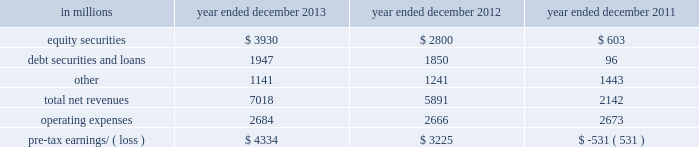Management 2019s discussion and analysis net revenues in equities were $ 8.21 billion for 2012 , essentially unchanged compared with 2011 .
Net revenues in securities services were significantly higher compared with 2011 , reflecting a gain of $ 494 million on the sale of our hedge fund administration business .
In addition , equities client execution net revenues were higher than 2011 , primarily reflecting significantly higher results in cash products , principally due to increased levels of client activity .
These increases were offset by lower commissions and fees , reflecting declines in the united states , europe and asia .
Our average daily volumes during 2012 were lower in each of these regions compared with 2011 , consistent with listed cash equity market volumes .
During 2012 , equities operated in an environment generally characterized by an increase in global equity prices and lower volatility levels .
The net loss attributable to the impact of changes in our own credit spreads on borrowings for which the fair value option was elected was $ 714 million ( $ 433 million and $ 281 million related to fixed income , currency and commodities client execution and equities client execution , respectively ) for 2012 , compared with a net gain of $ 596 million ( $ 399 million and $ 197 million related to fixed income , currency and commodities client execution and equities client execution , respectively ) for 2011 .
During 2012 , institutional client services operated in an environment generally characterized by continued broad market concerns and uncertainties , although positive developments helped to improve market conditions .
These developments included certain central bank actions to ease monetary policy and address funding risks for european financial institutions .
In addition , the u.s .
Economy posted stable to improving economic data , including favorable developments in unemployment and housing .
These improvements resulted in tighter credit spreads , higher global equity prices and lower levels of volatility .
However , concerns about the outlook for the global economy and continued political uncertainty , particularly the political debate in the united states surrounding the fiscal cliff , generally resulted in client risk aversion and lower activity levels .
Also , uncertainty over financial regulatory reform persisted .
Operating expenses were $ 12.48 billion for 2012 , 3% ( 3 % ) lower than 2011 , primarily due to lower brokerage , clearing , exchange and distribution fees , and lower impairment charges , partially offset by higher net provisions for litigation and regulatory proceedings .
Pre- tax earnings were $ 5.64 billion in 2012 , 27% ( 27 % ) higher than 2011 .
Investing & lending investing & lending includes our investing activities and the origination of loans to provide financing to clients .
These investments , some of which are consolidated , and loans are typically longer-term in nature .
We make investments , directly and indirectly through funds that we manage , in debt securities and loans , public and private equity securities , and real estate entities .
The table below presents the operating results of our investing & lending segment. .
2013 versus 2012 .
Net revenues in investing & lending were $ 7.02 billion for 2013 , 19% ( 19 % ) higher than 2012 , reflecting a significant increase in net gains from investments in equity securities , driven by company-specific events and stronger corporate performance , as well as significantly higher global equity prices .
In addition , net gains and net interest income from debt securities and loans were slightly higher , while other net revenues , related to our consolidated investments , were lower compared with 2012 .
If equity markets decline or credit spreads widen , net revenues in investing & lending would likely be negatively impacted .
Operating expenses were $ 2.68 billion for 2013 , essentially unchanged compared with 2012 .
Operating expenses during 2013 included lower impairment charges and lower operating expenses related to consolidated investments , partially offset by increased compensation and benefits expenses due to higher net revenues compared with 2012 .
Pre-tax earnings were $ 4.33 billion in 2013 , 34% ( 34 % ) higher than 2012 .
52 goldman sachs 2013 annual report .
Operating expenses for 2012 , were what percent of pre- tax earnings? 
Computations: (12.48 / 5.64)
Answer: 2.21277. Management 2019s discussion and analysis net revenues in equities were $ 8.21 billion for 2012 , essentially unchanged compared with 2011 .
Net revenues in securities services were significantly higher compared with 2011 , reflecting a gain of $ 494 million on the sale of our hedge fund administration business .
In addition , equities client execution net revenues were higher than 2011 , primarily reflecting significantly higher results in cash products , principally due to increased levels of client activity .
These increases were offset by lower commissions and fees , reflecting declines in the united states , europe and asia .
Our average daily volumes during 2012 were lower in each of these regions compared with 2011 , consistent with listed cash equity market volumes .
During 2012 , equities operated in an environment generally characterized by an increase in global equity prices and lower volatility levels .
The net loss attributable to the impact of changes in our own credit spreads on borrowings for which the fair value option was elected was $ 714 million ( $ 433 million and $ 281 million related to fixed income , currency and commodities client execution and equities client execution , respectively ) for 2012 , compared with a net gain of $ 596 million ( $ 399 million and $ 197 million related to fixed income , currency and commodities client execution and equities client execution , respectively ) for 2011 .
During 2012 , institutional client services operated in an environment generally characterized by continued broad market concerns and uncertainties , although positive developments helped to improve market conditions .
These developments included certain central bank actions to ease monetary policy and address funding risks for european financial institutions .
In addition , the u.s .
Economy posted stable to improving economic data , including favorable developments in unemployment and housing .
These improvements resulted in tighter credit spreads , higher global equity prices and lower levels of volatility .
However , concerns about the outlook for the global economy and continued political uncertainty , particularly the political debate in the united states surrounding the fiscal cliff , generally resulted in client risk aversion and lower activity levels .
Also , uncertainty over financial regulatory reform persisted .
Operating expenses were $ 12.48 billion for 2012 , 3% ( 3 % ) lower than 2011 , primarily due to lower brokerage , clearing , exchange and distribution fees , and lower impairment charges , partially offset by higher net provisions for litigation and regulatory proceedings .
Pre- tax earnings were $ 5.64 billion in 2012 , 27% ( 27 % ) higher than 2011 .
Investing & lending investing & lending includes our investing activities and the origination of loans to provide financing to clients .
These investments , some of which are consolidated , and loans are typically longer-term in nature .
We make investments , directly and indirectly through funds that we manage , in debt securities and loans , public and private equity securities , and real estate entities .
The table below presents the operating results of our investing & lending segment. .
2013 versus 2012 .
Net revenues in investing & lending were $ 7.02 billion for 2013 , 19% ( 19 % ) higher than 2012 , reflecting a significant increase in net gains from investments in equity securities , driven by company-specific events and stronger corporate performance , as well as significantly higher global equity prices .
In addition , net gains and net interest income from debt securities and loans were slightly higher , while other net revenues , related to our consolidated investments , were lower compared with 2012 .
If equity markets decline or credit spreads widen , net revenues in investing & lending would likely be negatively impacted .
Operating expenses were $ 2.68 billion for 2013 , essentially unchanged compared with 2012 .
Operating expenses during 2013 included lower impairment charges and lower operating expenses related to consolidated investments , partially offset by increased compensation and benefits expenses due to higher net revenues compared with 2012 .
Pre-tax earnings were $ 4.33 billion in 2013 , 34% ( 34 % ) higher than 2012 .
52 goldman sachs 2013 annual report .
What percentage of total net revenues investing & lending segment were attributable to equity securities in 2012? 
Computations: (2800 / 5891)
Answer: 0.4753. 